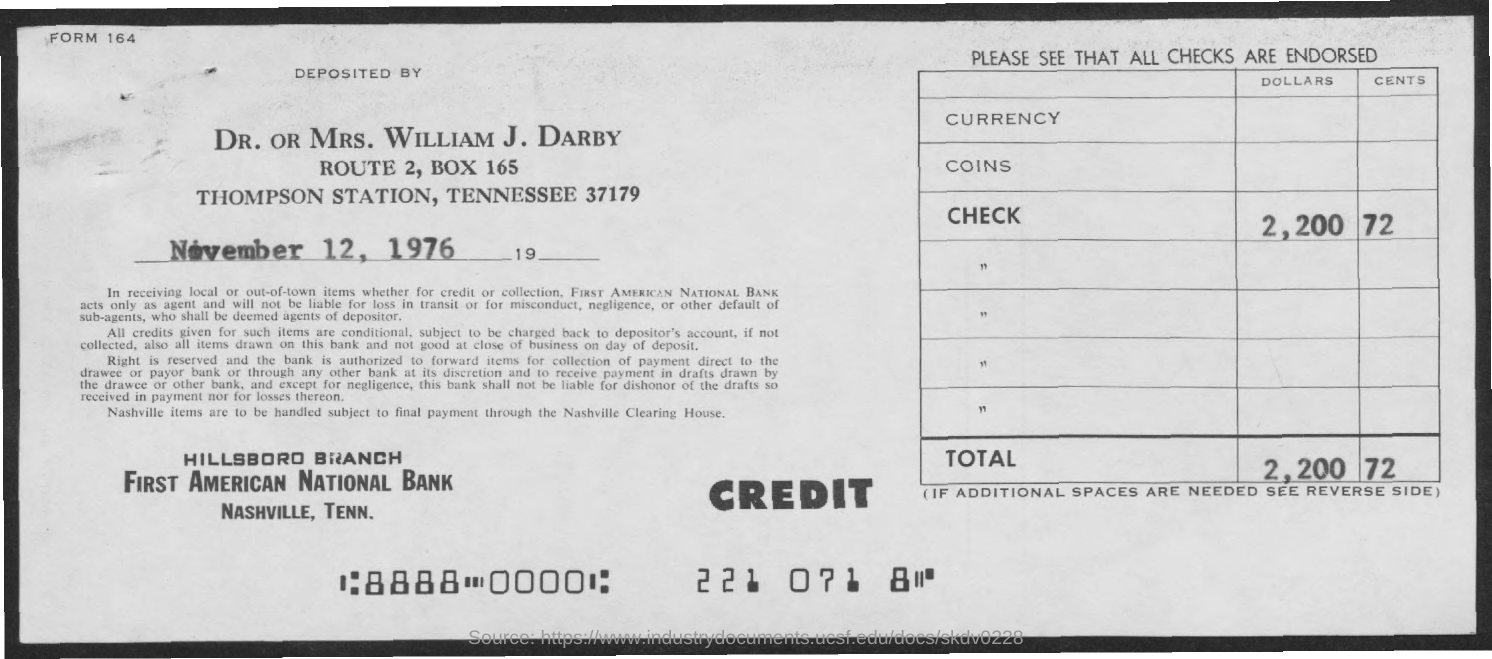Point out several critical features in this image. First American National Bank is the name of the bank mentioned. The amount mentioned in the check is 72 cents. The date mentioned on the given page is November 12, 1976. The Hillsboro Branch is the name of the branch mentioned. The box number mentioned is 165. 